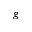Convert formula to latex. <formula><loc_0><loc_0><loc_500><loc_500>g</formula> 